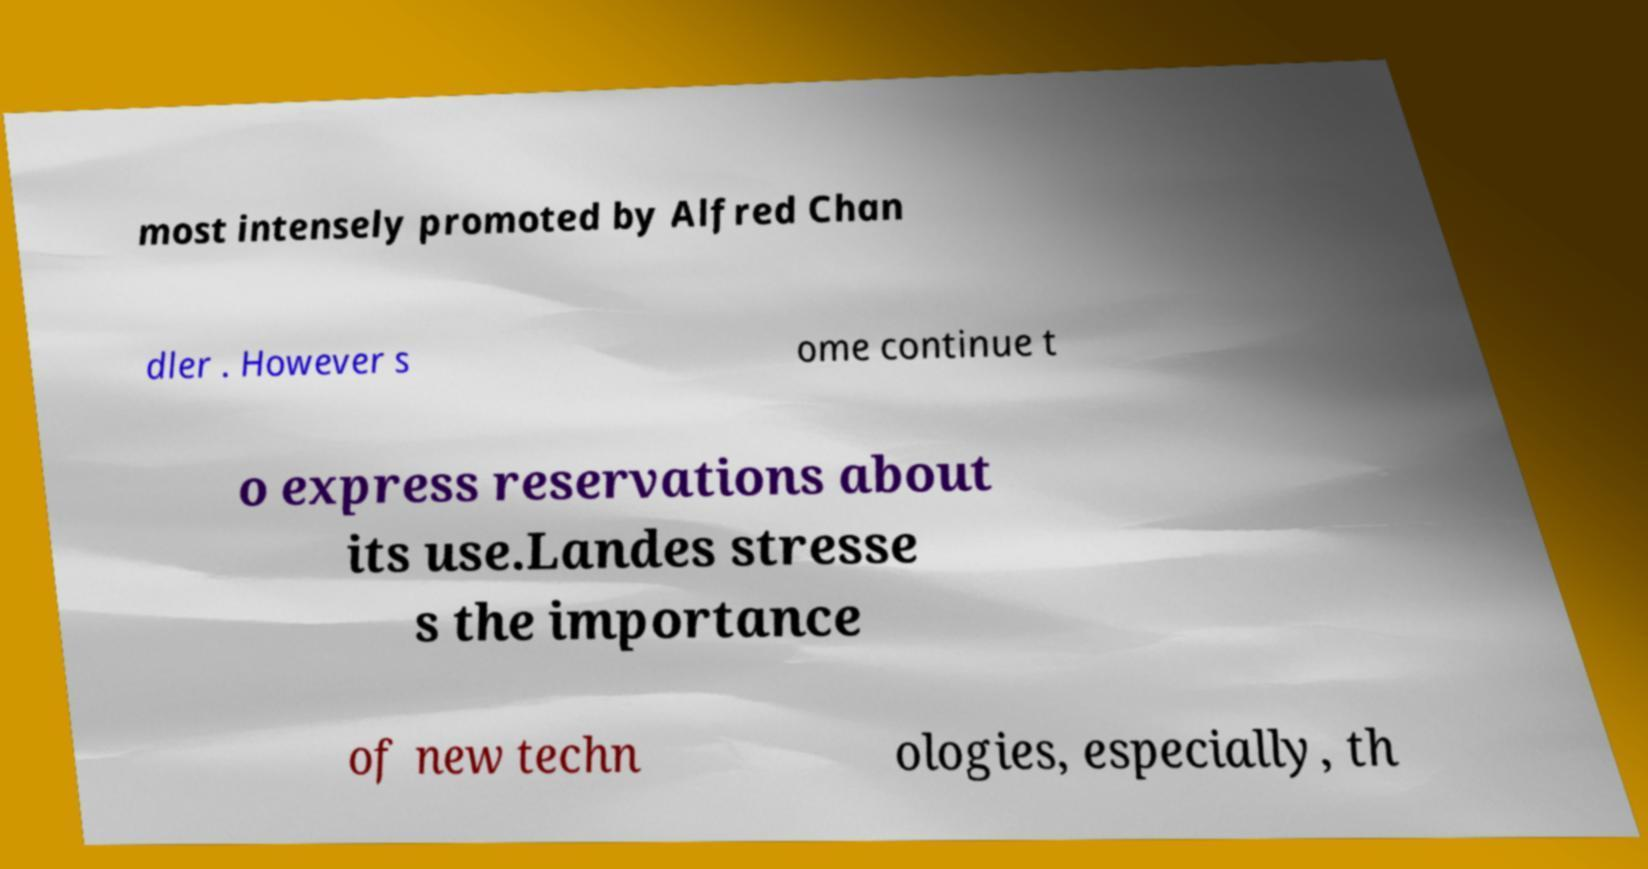Please read and relay the text visible in this image. What does it say? most intensely promoted by Alfred Chan dler . However s ome continue t o express reservations about its use.Landes stresse s the importance of new techn ologies, especially, th 